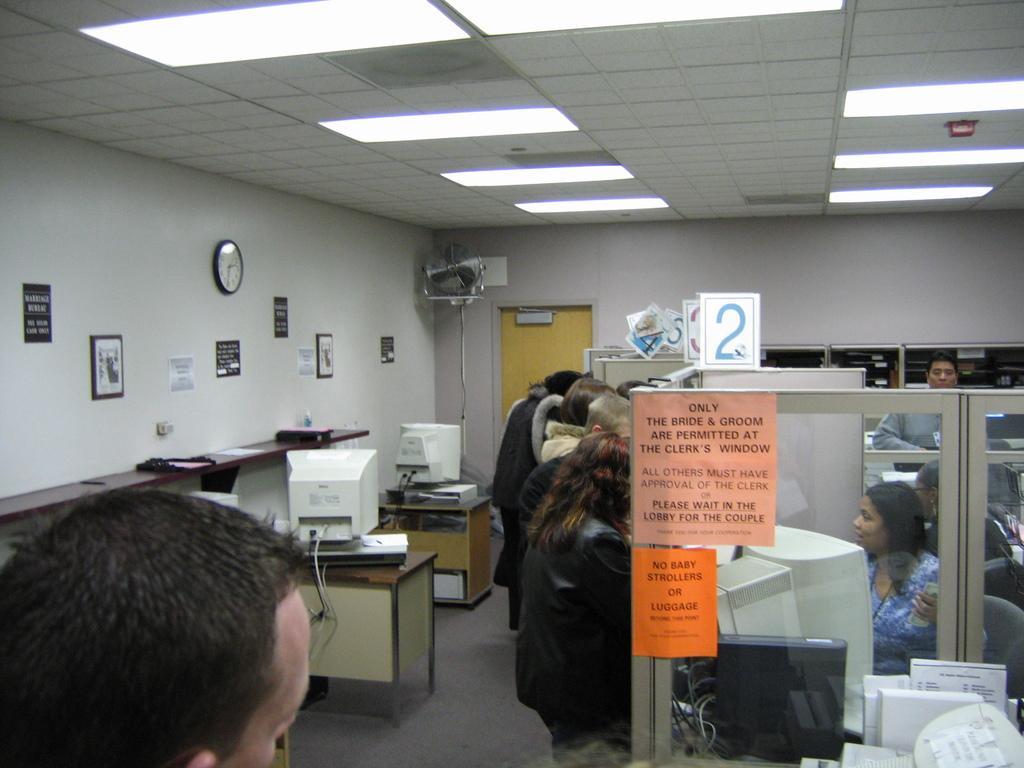How would you summarize this image in a sentence or two? In this image i can see few people standing and few people sitting on chairs, i can see monitors on the desks. In the background i can see a wall,the ceiling, a clock, few photos attached to the wall and a fan. 